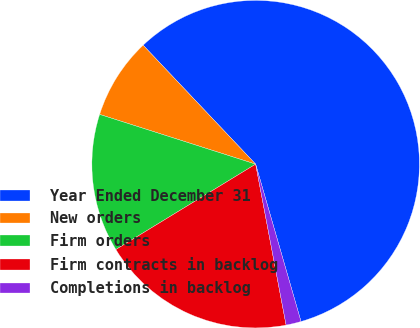Convert chart. <chart><loc_0><loc_0><loc_500><loc_500><pie_chart><fcel>Year Ended December 31<fcel>New orders<fcel>Firm orders<fcel>Firm contracts in backlog<fcel>Completions in backlog<nl><fcel>57.59%<fcel>8.03%<fcel>13.64%<fcel>19.25%<fcel>1.49%<nl></chart> 